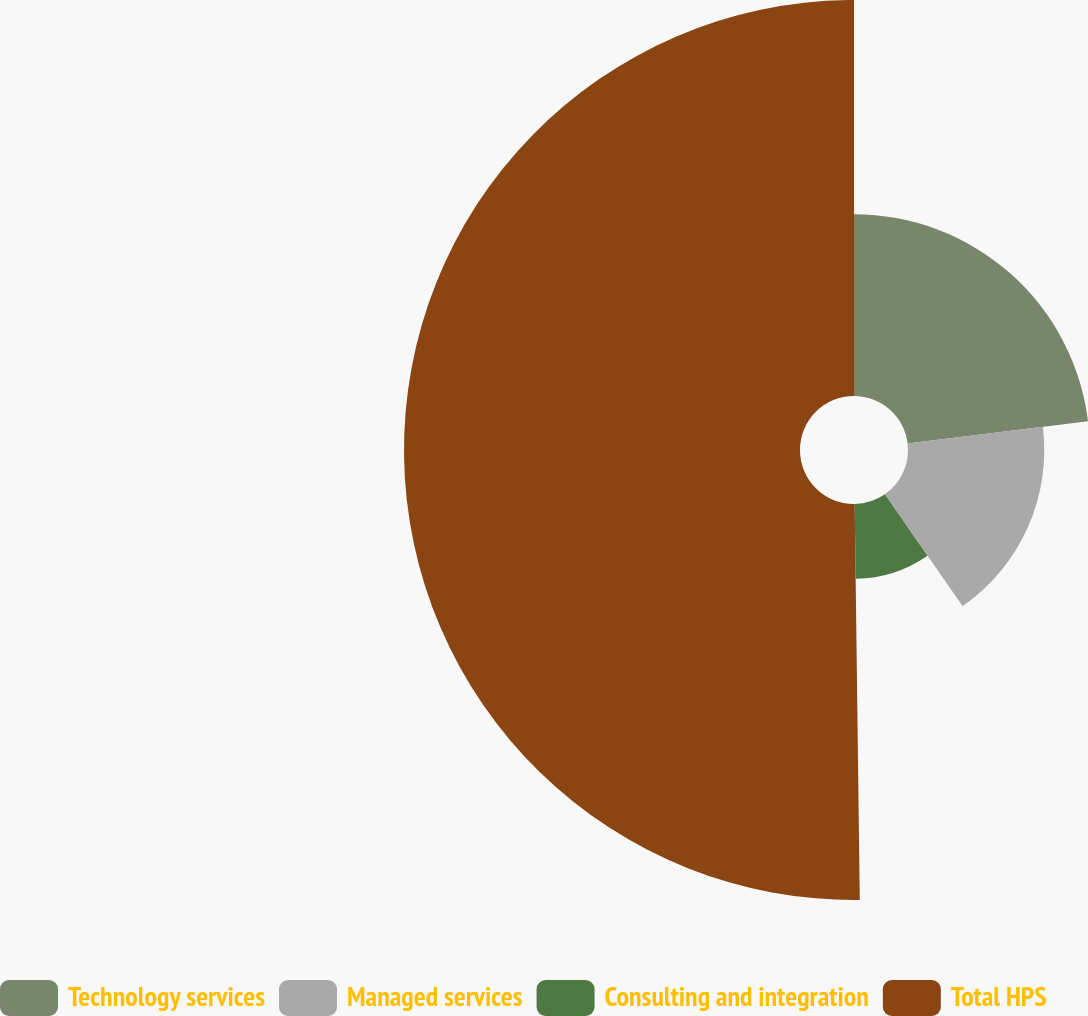Convert chart. <chart><loc_0><loc_0><loc_500><loc_500><pie_chart><fcel>Technology services<fcel>Managed services<fcel>Consulting and integration<fcel>Total HPS<nl><fcel>23.05%<fcel>17.28%<fcel>9.47%<fcel>50.21%<nl></chart> 